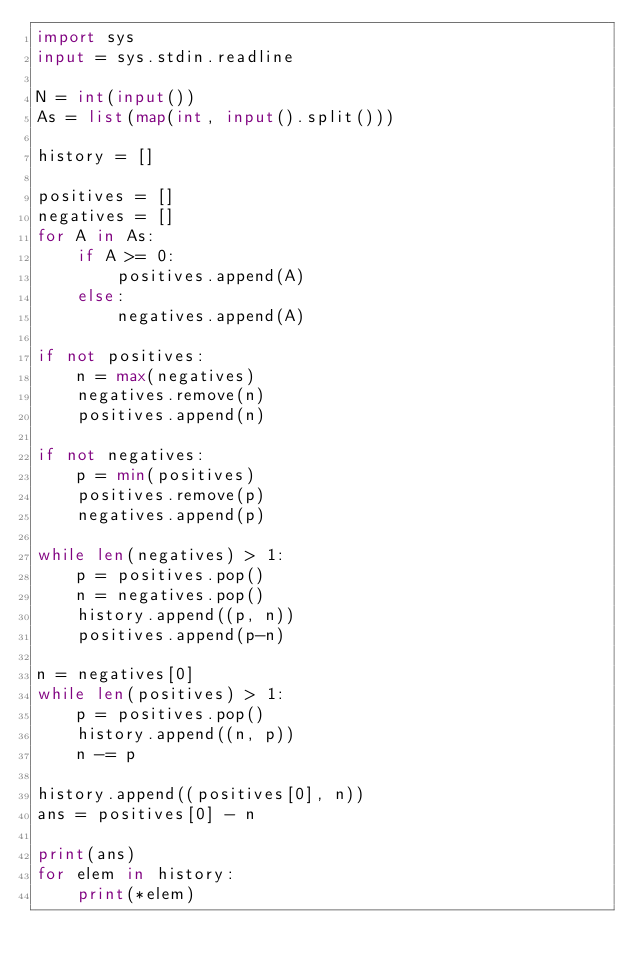<code> <loc_0><loc_0><loc_500><loc_500><_Python_>import sys
input = sys.stdin.readline

N = int(input())
As = list(map(int, input().split()))

history = []

positives = []
negatives = []
for A in As:
    if A >= 0:
        positives.append(A)
    else:
        negatives.append(A)

if not positives:
    n = max(negatives)
    negatives.remove(n)
    positives.append(n)

if not negatives:
    p = min(positives)
    positives.remove(p)
    negatives.append(p)

while len(negatives) > 1:
    p = positives.pop()
    n = negatives.pop()
    history.append((p, n))
    positives.append(p-n)

n = negatives[0]
while len(positives) > 1:
    p = positives.pop()
    history.append((n, p))
    n -= p

history.append((positives[0], n))
ans = positives[0] - n

print(ans)
for elem in history:
    print(*elem)</code> 